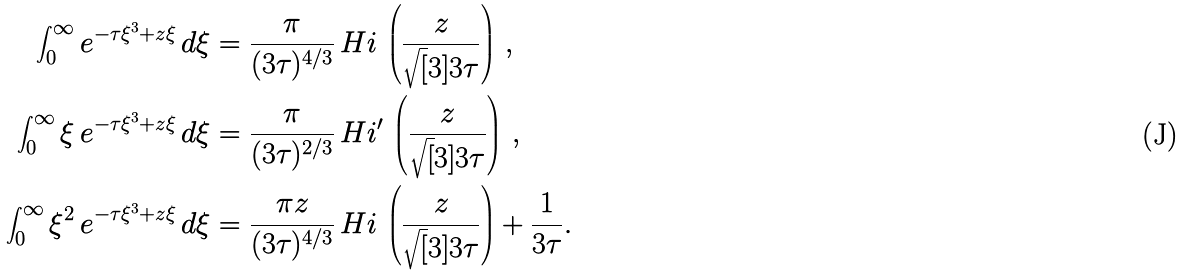Convert formula to latex. <formula><loc_0><loc_0><loc_500><loc_500>\int _ { 0 } ^ { \infty } e ^ { - \tau \xi ^ { 3 } + z \xi } \, d \xi & = \frac { \pi } { ( 3 \tau ) ^ { 4 / 3 } } \, H i \, \left ( \frac { z } { \sqrt { [ } 3 ] { 3 \tau } } \right ) \, , \\ \int _ { 0 } ^ { \infty } \xi \, e ^ { - \tau \xi ^ { 3 } + z \xi } \, d \xi & = \frac { \pi } { ( 3 \tau ) ^ { 2 / 3 } } \, H i ^ { \prime } \, \left ( \frac { z } { \sqrt { [ } 3 ] { 3 \tau } } \right ) \, , \\ \int _ { 0 } ^ { \infty } \xi ^ { 2 } \, e ^ { - \tau \xi ^ { 3 } + z \xi } \, d \xi & = \frac { \pi z } { ( 3 \tau ) ^ { 4 / 3 } } \, H i \, \left ( \frac { z } { \sqrt { [ } 3 ] { 3 \tau } } \right ) + \frac { 1 } { 3 \tau } .</formula> 